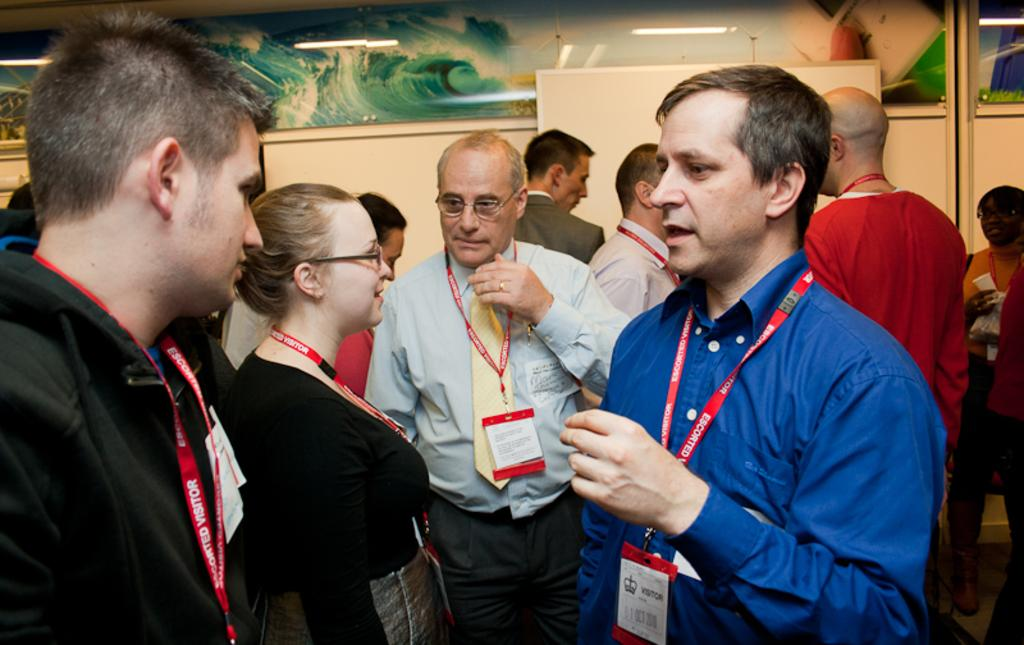How many people are in the image? There are many people in the image. What can be seen on the people in the image? The people are wearing tags. What is visible in the background of the image? There is a wall in the background of the image. What is on the wall in the image? There is a glass painting on the wall. What is the glass painting doing in the image? The glass painting reflects tube lights. What type of disease is being discussed by the people in the image? There is no indication in the image that the people are discussing any disease. 